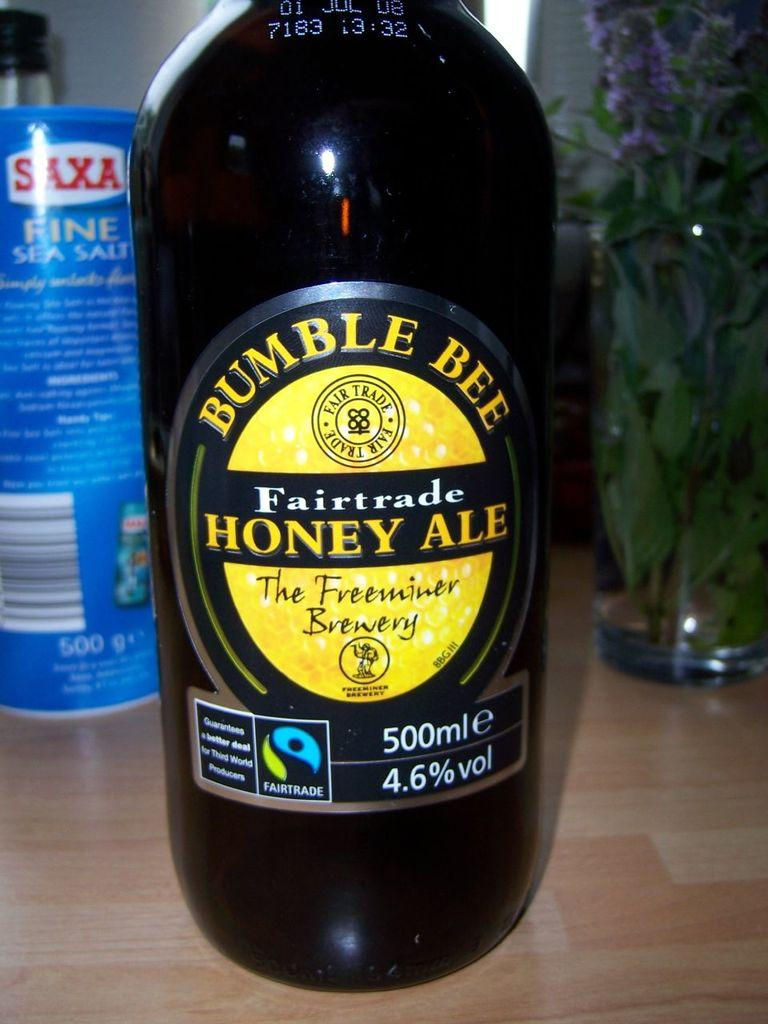<image>
Describe the image concisely. A bottle of Bumble Bee Fairtrade Honey Ale 